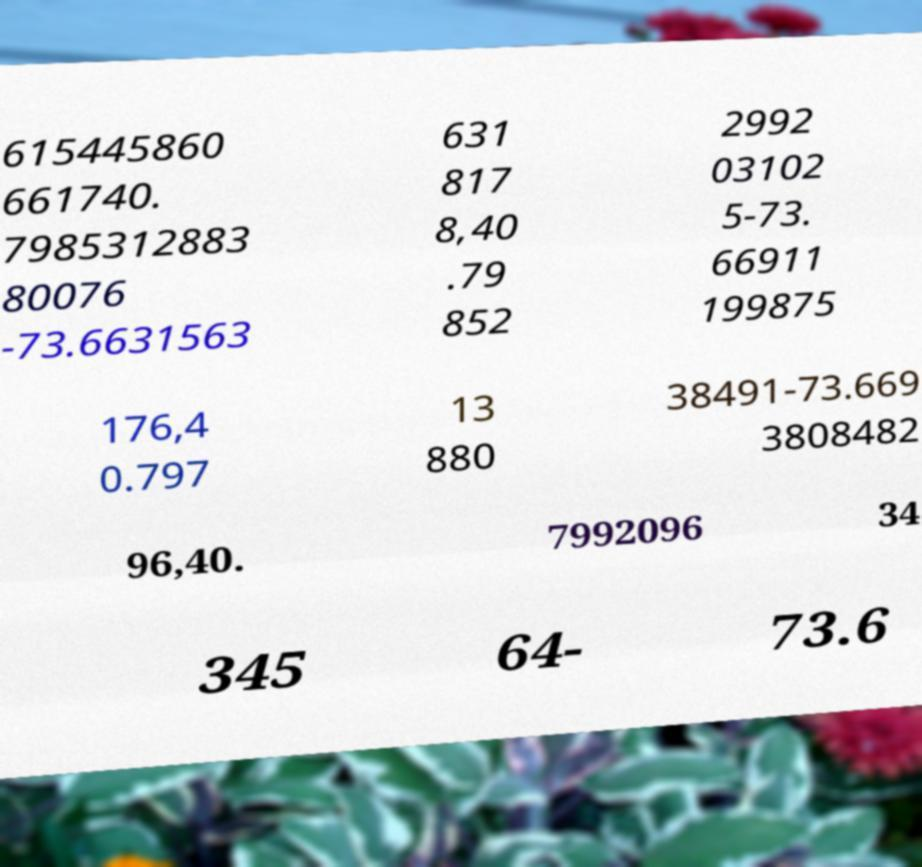I need the written content from this picture converted into text. Can you do that? 615445860 661740. 7985312883 80076 -73.6631563 631 817 8,40 .79 852 2992 03102 5-73. 66911 199875 176,4 0.797 13 880 38491-73.669 3808482 96,40. 7992096 34 345 64- 73.6 